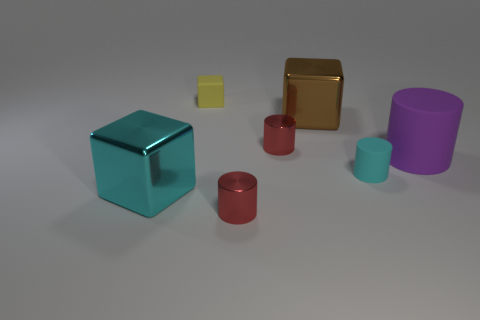Subtract all green cylinders. Subtract all red spheres. How many cylinders are left? 4 Add 1 red things. How many objects exist? 8 Subtract all cylinders. How many objects are left? 3 Subtract 0 green blocks. How many objects are left? 7 Subtract all red cylinders. Subtract all cyan objects. How many objects are left? 3 Add 5 tiny matte cubes. How many tiny matte cubes are left? 6 Add 6 purple rubber objects. How many purple rubber objects exist? 7 